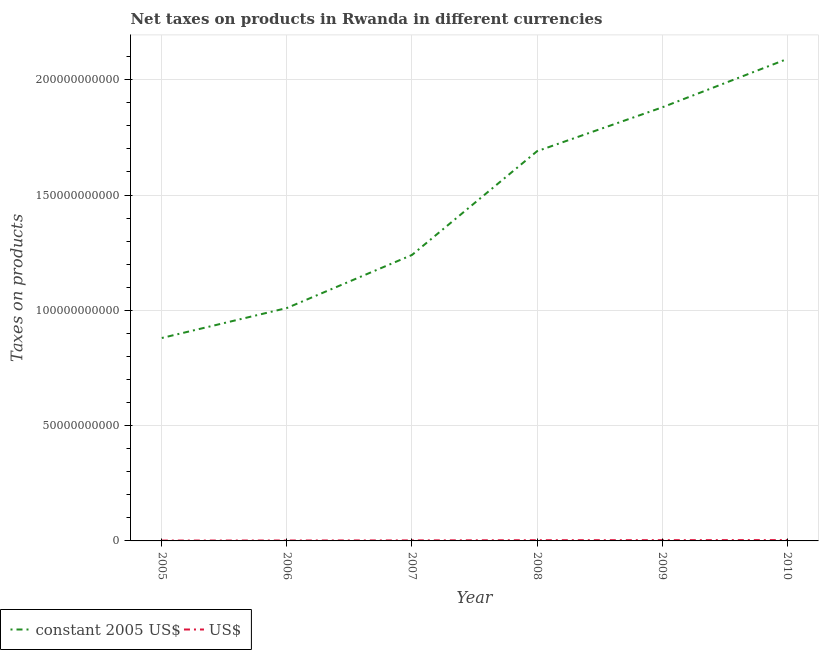How many different coloured lines are there?
Make the answer very short. 2. Does the line corresponding to net taxes in us$ intersect with the line corresponding to net taxes in constant 2005 us$?
Offer a terse response. No. Is the number of lines equal to the number of legend labels?
Provide a succinct answer. Yes. What is the net taxes in constant 2005 us$ in 2009?
Your answer should be compact. 1.88e+11. Across all years, what is the maximum net taxes in constant 2005 us$?
Keep it short and to the point. 2.09e+11. Across all years, what is the minimum net taxes in constant 2005 us$?
Your answer should be compact. 8.80e+1. In which year was the net taxes in constant 2005 us$ maximum?
Offer a very short reply. 2010. In which year was the net taxes in us$ minimum?
Give a very brief answer. 2005. What is the total net taxes in constant 2005 us$ in the graph?
Offer a very short reply. 8.79e+11. What is the difference between the net taxes in us$ in 2007 and that in 2009?
Your answer should be compact. -1.04e+08. What is the difference between the net taxes in us$ in 2005 and the net taxes in constant 2005 us$ in 2010?
Provide a succinct answer. -2.09e+11. What is the average net taxes in constant 2005 us$ per year?
Give a very brief answer. 1.46e+11. In the year 2010, what is the difference between the net taxes in constant 2005 us$ and net taxes in us$?
Your response must be concise. 2.09e+11. What is the ratio of the net taxes in us$ in 2005 to that in 2008?
Offer a terse response. 0.51. Is the difference between the net taxes in constant 2005 us$ in 2006 and 2007 greater than the difference between the net taxes in us$ in 2006 and 2007?
Offer a terse response. No. What is the difference between the highest and the second highest net taxes in constant 2005 us$?
Your answer should be compact. 2.10e+1. What is the difference between the highest and the lowest net taxes in constant 2005 us$?
Make the answer very short. 1.21e+11. Does the net taxes in us$ monotonically increase over the years?
Your answer should be compact. Yes. Is the net taxes in us$ strictly less than the net taxes in constant 2005 us$ over the years?
Keep it short and to the point. Yes. How many lines are there?
Offer a very short reply. 2. How many years are there in the graph?
Provide a succinct answer. 6. Are the values on the major ticks of Y-axis written in scientific E-notation?
Provide a short and direct response. No. Does the graph contain grids?
Ensure brevity in your answer.  Yes. What is the title of the graph?
Offer a very short reply. Net taxes on products in Rwanda in different currencies. Does "Adolescent fertility rate" appear as one of the legend labels in the graph?
Your response must be concise. No. What is the label or title of the Y-axis?
Keep it short and to the point. Taxes on products. What is the Taxes on products of constant 2005 US$ in 2005?
Your answer should be compact. 8.80e+1. What is the Taxes on products of US$ in 2005?
Your response must be concise. 1.58e+08. What is the Taxes on products of constant 2005 US$ in 2006?
Ensure brevity in your answer.  1.01e+11. What is the Taxes on products of US$ in 2006?
Your response must be concise. 1.83e+08. What is the Taxes on products of constant 2005 US$ in 2007?
Make the answer very short. 1.24e+11. What is the Taxes on products in US$ in 2007?
Give a very brief answer. 2.27e+08. What is the Taxes on products in constant 2005 US$ in 2008?
Provide a short and direct response. 1.69e+11. What is the Taxes on products in US$ in 2008?
Your response must be concise. 3.09e+08. What is the Taxes on products of constant 2005 US$ in 2009?
Keep it short and to the point. 1.88e+11. What is the Taxes on products in US$ in 2009?
Keep it short and to the point. 3.31e+08. What is the Taxes on products of constant 2005 US$ in 2010?
Your response must be concise. 2.09e+11. What is the Taxes on products in US$ in 2010?
Your answer should be compact. 3.58e+08. Across all years, what is the maximum Taxes on products in constant 2005 US$?
Your answer should be compact. 2.09e+11. Across all years, what is the maximum Taxes on products in US$?
Provide a succinct answer. 3.58e+08. Across all years, what is the minimum Taxes on products of constant 2005 US$?
Provide a succinct answer. 8.80e+1. Across all years, what is the minimum Taxes on products in US$?
Make the answer very short. 1.58e+08. What is the total Taxes on products of constant 2005 US$ in the graph?
Give a very brief answer. 8.79e+11. What is the total Taxes on products of US$ in the graph?
Provide a succinct answer. 1.57e+09. What is the difference between the Taxes on products in constant 2005 US$ in 2005 and that in 2006?
Your answer should be compact. -1.30e+1. What is the difference between the Taxes on products of US$ in 2005 and that in 2006?
Offer a terse response. -2.53e+07. What is the difference between the Taxes on products of constant 2005 US$ in 2005 and that in 2007?
Provide a short and direct response. -3.60e+1. What is the difference between the Taxes on products in US$ in 2005 and that in 2007?
Your answer should be compact. -6.90e+07. What is the difference between the Taxes on products of constant 2005 US$ in 2005 and that in 2008?
Ensure brevity in your answer.  -8.10e+1. What is the difference between the Taxes on products in US$ in 2005 and that in 2008?
Ensure brevity in your answer.  -1.51e+08. What is the difference between the Taxes on products in constant 2005 US$ in 2005 and that in 2009?
Offer a terse response. -1.00e+11. What is the difference between the Taxes on products in US$ in 2005 and that in 2009?
Make the answer very short. -1.73e+08. What is the difference between the Taxes on products of constant 2005 US$ in 2005 and that in 2010?
Make the answer very short. -1.21e+11. What is the difference between the Taxes on products in US$ in 2005 and that in 2010?
Provide a short and direct response. -2.01e+08. What is the difference between the Taxes on products of constant 2005 US$ in 2006 and that in 2007?
Give a very brief answer. -2.30e+1. What is the difference between the Taxes on products in US$ in 2006 and that in 2007?
Keep it short and to the point. -4.36e+07. What is the difference between the Taxes on products in constant 2005 US$ in 2006 and that in 2008?
Your response must be concise. -6.80e+1. What is the difference between the Taxes on products of US$ in 2006 and that in 2008?
Your answer should be compact. -1.26e+08. What is the difference between the Taxes on products of constant 2005 US$ in 2006 and that in 2009?
Ensure brevity in your answer.  -8.70e+1. What is the difference between the Taxes on products in US$ in 2006 and that in 2009?
Make the answer very short. -1.48e+08. What is the difference between the Taxes on products of constant 2005 US$ in 2006 and that in 2010?
Offer a terse response. -1.08e+11. What is the difference between the Taxes on products in US$ in 2006 and that in 2010?
Your answer should be very brief. -1.75e+08. What is the difference between the Taxes on products of constant 2005 US$ in 2007 and that in 2008?
Make the answer very short. -4.50e+1. What is the difference between the Taxes on products in US$ in 2007 and that in 2008?
Keep it short and to the point. -8.23e+07. What is the difference between the Taxes on products of constant 2005 US$ in 2007 and that in 2009?
Your answer should be very brief. -6.40e+1. What is the difference between the Taxes on products in US$ in 2007 and that in 2009?
Provide a short and direct response. -1.04e+08. What is the difference between the Taxes on products of constant 2005 US$ in 2007 and that in 2010?
Keep it short and to the point. -8.50e+1. What is the difference between the Taxes on products of US$ in 2007 and that in 2010?
Make the answer very short. -1.32e+08. What is the difference between the Taxes on products in constant 2005 US$ in 2008 and that in 2009?
Give a very brief answer. -1.90e+1. What is the difference between the Taxes on products in US$ in 2008 and that in 2009?
Provide a succinct answer. -2.18e+07. What is the difference between the Taxes on products in constant 2005 US$ in 2008 and that in 2010?
Make the answer very short. -4.00e+1. What is the difference between the Taxes on products of US$ in 2008 and that in 2010?
Keep it short and to the point. -4.94e+07. What is the difference between the Taxes on products in constant 2005 US$ in 2009 and that in 2010?
Ensure brevity in your answer.  -2.10e+1. What is the difference between the Taxes on products in US$ in 2009 and that in 2010?
Offer a terse response. -2.76e+07. What is the difference between the Taxes on products of constant 2005 US$ in 2005 and the Taxes on products of US$ in 2006?
Your answer should be very brief. 8.78e+1. What is the difference between the Taxes on products of constant 2005 US$ in 2005 and the Taxes on products of US$ in 2007?
Provide a short and direct response. 8.78e+1. What is the difference between the Taxes on products in constant 2005 US$ in 2005 and the Taxes on products in US$ in 2008?
Offer a terse response. 8.77e+1. What is the difference between the Taxes on products of constant 2005 US$ in 2005 and the Taxes on products of US$ in 2009?
Your answer should be very brief. 8.77e+1. What is the difference between the Taxes on products of constant 2005 US$ in 2005 and the Taxes on products of US$ in 2010?
Provide a succinct answer. 8.76e+1. What is the difference between the Taxes on products in constant 2005 US$ in 2006 and the Taxes on products in US$ in 2007?
Your response must be concise. 1.01e+11. What is the difference between the Taxes on products of constant 2005 US$ in 2006 and the Taxes on products of US$ in 2008?
Offer a terse response. 1.01e+11. What is the difference between the Taxes on products in constant 2005 US$ in 2006 and the Taxes on products in US$ in 2009?
Offer a very short reply. 1.01e+11. What is the difference between the Taxes on products of constant 2005 US$ in 2006 and the Taxes on products of US$ in 2010?
Provide a succinct answer. 1.01e+11. What is the difference between the Taxes on products of constant 2005 US$ in 2007 and the Taxes on products of US$ in 2008?
Give a very brief answer. 1.24e+11. What is the difference between the Taxes on products of constant 2005 US$ in 2007 and the Taxes on products of US$ in 2009?
Provide a short and direct response. 1.24e+11. What is the difference between the Taxes on products of constant 2005 US$ in 2007 and the Taxes on products of US$ in 2010?
Ensure brevity in your answer.  1.24e+11. What is the difference between the Taxes on products in constant 2005 US$ in 2008 and the Taxes on products in US$ in 2009?
Provide a succinct answer. 1.69e+11. What is the difference between the Taxes on products of constant 2005 US$ in 2008 and the Taxes on products of US$ in 2010?
Ensure brevity in your answer.  1.69e+11. What is the difference between the Taxes on products in constant 2005 US$ in 2009 and the Taxes on products in US$ in 2010?
Give a very brief answer. 1.88e+11. What is the average Taxes on products of constant 2005 US$ per year?
Provide a short and direct response. 1.46e+11. What is the average Taxes on products in US$ per year?
Ensure brevity in your answer.  2.61e+08. In the year 2005, what is the difference between the Taxes on products of constant 2005 US$ and Taxes on products of US$?
Offer a terse response. 8.78e+1. In the year 2006, what is the difference between the Taxes on products in constant 2005 US$ and Taxes on products in US$?
Your answer should be compact. 1.01e+11. In the year 2007, what is the difference between the Taxes on products of constant 2005 US$ and Taxes on products of US$?
Offer a very short reply. 1.24e+11. In the year 2008, what is the difference between the Taxes on products in constant 2005 US$ and Taxes on products in US$?
Provide a short and direct response. 1.69e+11. In the year 2009, what is the difference between the Taxes on products of constant 2005 US$ and Taxes on products of US$?
Offer a very short reply. 1.88e+11. In the year 2010, what is the difference between the Taxes on products in constant 2005 US$ and Taxes on products in US$?
Your response must be concise. 2.09e+11. What is the ratio of the Taxes on products in constant 2005 US$ in 2005 to that in 2006?
Offer a terse response. 0.87. What is the ratio of the Taxes on products of US$ in 2005 to that in 2006?
Give a very brief answer. 0.86. What is the ratio of the Taxes on products of constant 2005 US$ in 2005 to that in 2007?
Your answer should be compact. 0.71. What is the ratio of the Taxes on products in US$ in 2005 to that in 2007?
Provide a short and direct response. 0.7. What is the ratio of the Taxes on products of constant 2005 US$ in 2005 to that in 2008?
Provide a succinct answer. 0.52. What is the ratio of the Taxes on products in US$ in 2005 to that in 2008?
Provide a short and direct response. 0.51. What is the ratio of the Taxes on products of constant 2005 US$ in 2005 to that in 2009?
Provide a succinct answer. 0.47. What is the ratio of the Taxes on products of US$ in 2005 to that in 2009?
Keep it short and to the point. 0.48. What is the ratio of the Taxes on products in constant 2005 US$ in 2005 to that in 2010?
Your response must be concise. 0.42. What is the ratio of the Taxes on products in US$ in 2005 to that in 2010?
Provide a short and direct response. 0.44. What is the ratio of the Taxes on products of constant 2005 US$ in 2006 to that in 2007?
Your answer should be compact. 0.81. What is the ratio of the Taxes on products in US$ in 2006 to that in 2007?
Keep it short and to the point. 0.81. What is the ratio of the Taxes on products of constant 2005 US$ in 2006 to that in 2008?
Your response must be concise. 0.6. What is the ratio of the Taxes on products in US$ in 2006 to that in 2008?
Provide a short and direct response. 0.59. What is the ratio of the Taxes on products in constant 2005 US$ in 2006 to that in 2009?
Your answer should be very brief. 0.54. What is the ratio of the Taxes on products in US$ in 2006 to that in 2009?
Provide a succinct answer. 0.55. What is the ratio of the Taxes on products of constant 2005 US$ in 2006 to that in 2010?
Provide a short and direct response. 0.48. What is the ratio of the Taxes on products of US$ in 2006 to that in 2010?
Your answer should be compact. 0.51. What is the ratio of the Taxes on products of constant 2005 US$ in 2007 to that in 2008?
Offer a very short reply. 0.73. What is the ratio of the Taxes on products of US$ in 2007 to that in 2008?
Keep it short and to the point. 0.73. What is the ratio of the Taxes on products in constant 2005 US$ in 2007 to that in 2009?
Offer a terse response. 0.66. What is the ratio of the Taxes on products in US$ in 2007 to that in 2009?
Offer a very short reply. 0.69. What is the ratio of the Taxes on products in constant 2005 US$ in 2007 to that in 2010?
Your response must be concise. 0.59. What is the ratio of the Taxes on products of US$ in 2007 to that in 2010?
Provide a succinct answer. 0.63. What is the ratio of the Taxes on products of constant 2005 US$ in 2008 to that in 2009?
Your answer should be compact. 0.9. What is the ratio of the Taxes on products in US$ in 2008 to that in 2009?
Your answer should be compact. 0.93. What is the ratio of the Taxes on products of constant 2005 US$ in 2008 to that in 2010?
Provide a succinct answer. 0.81. What is the ratio of the Taxes on products in US$ in 2008 to that in 2010?
Your answer should be very brief. 0.86. What is the ratio of the Taxes on products in constant 2005 US$ in 2009 to that in 2010?
Provide a short and direct response. 0.9. What is the ratio of the Taxes on products in US$ in 2009 to that in 2010?
Give a very brief answer. 0.92. What is the difference between the highest and the second highest Taxes on products of constant 2005 US$?
Offer a very short reply. 2.10e+1. What is the difference between the highest and the second highest Taxes on products of US$?
Provide a succinct answer. 2.76e+07. What is the difference between the highest and the lowest Taxes on products of constant 2005 US$?
Provide a short and direct response. 1.21e+11. What is the difference between the highest and the lowest Taxes on products in US$?
Your response must be concise. 2.01e+08. 